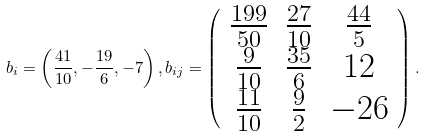Convert formula to latex. <formula><loc_0><loc_0><loc_500><loc_500>b _ { i } = \left ( \frac { 4 1 } { 1 0 } , - \frac { 1 9 } { 6 } , - 7 \right ) , { b _ { i j } } = \left ( \begin{array} { c c c } \frac { 1 9 9 } { 5 0 } & \frac { 2 7 } { 1 0 } & \frac { 4 4 } { 5 } \\ \frac { 9 } { 1 0 } & \frac { 3 5 } { 6 } & 1 2 \\ \frac { 1 1 } { 1 0 } & \frac { 9 } { 2 } & - 2 6 \end{array} \right ) .</formula> 